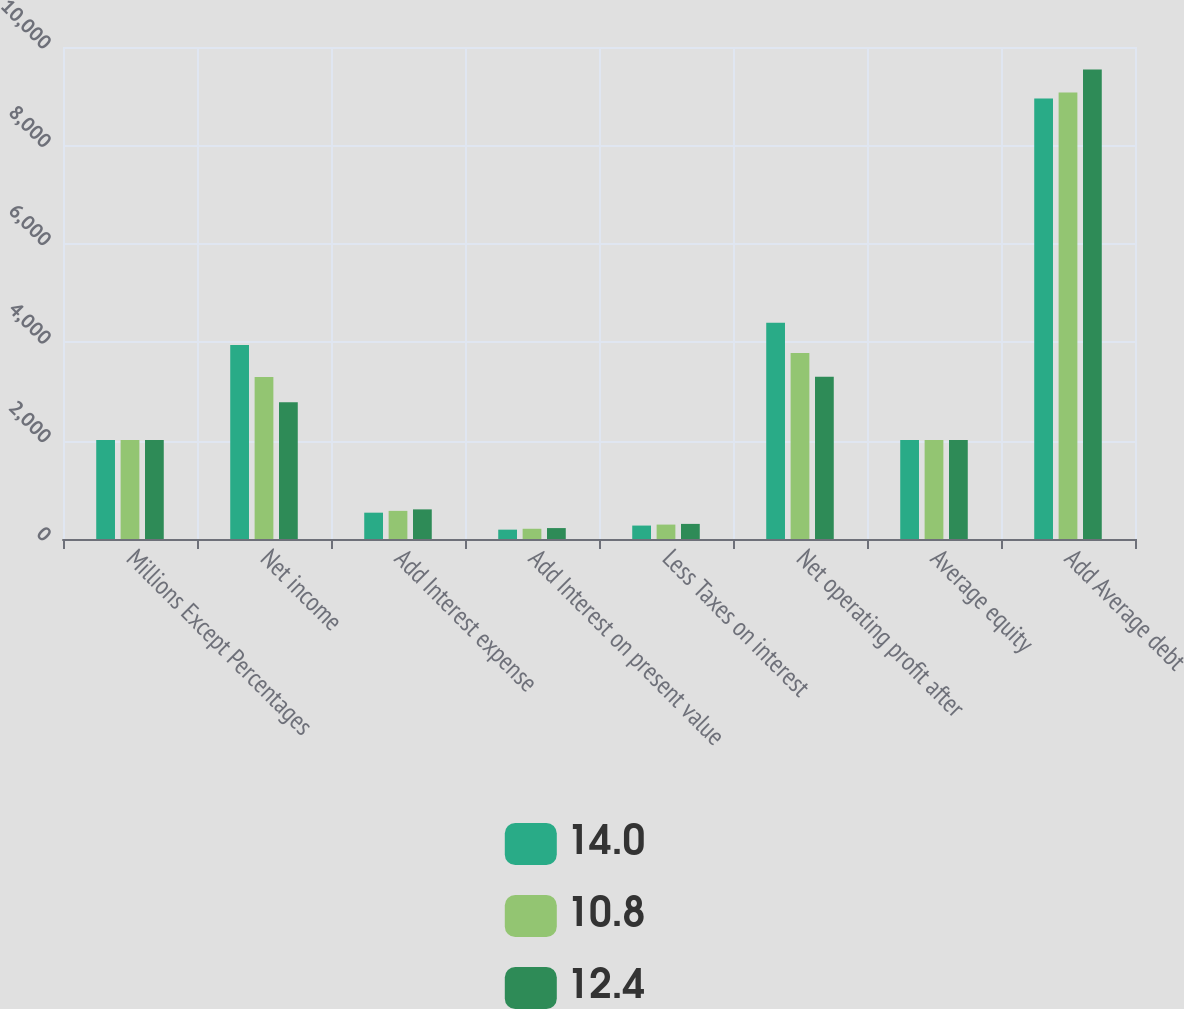<chart> <loc_0><loc_0><loc_500><loc_500><stacked_bar_chart><ecel><fcel>Millions Except Percentages<fcel>Net income<fcel>Add Interest expense<fcel>Add Interest on present value<fcel>Less Taxes on interest<fcel>Net operating profit after<fcel>Average equity<fcel>Add Average debt<nl><fcel>14<fcel>2012<fcel>3943<fcel>535<fcel>190<fcel>273<fcel>4395<fcel>2011<fcel>8952<nl><fcel>10.8<fcel>2011<fcel>3292<fcel>572<fcel>208<fcel>293<fcel>3779<fcel>2011<fcel>9074<nl><fcel>12.4<fcel>2010<fcel>2780<fcel>602<fcel>222<fcel>307<fcel>3297<fcel>2011<fcel>9545<nl></chart> 